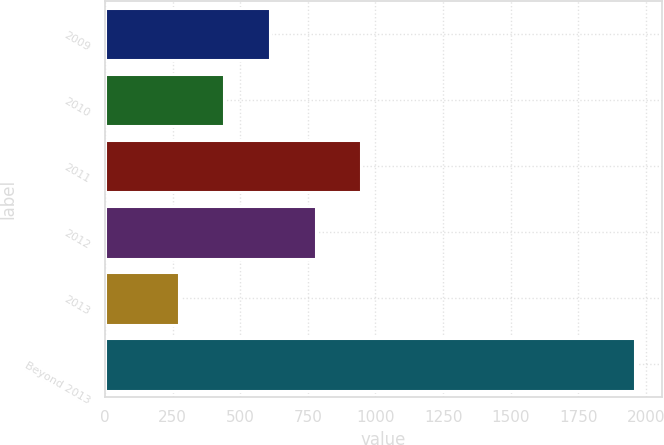Convert chart. <chart><loc_0><loc_0><loc_500><loc_500><bar_chart><fcel>2009<fcel>2010<fcel>2011<fcel>2012<fcel>2013<fcel>Beyond 2013<nl><fcel>610.4<fcel>441.7<fcel>947.8<fcel>779.1<fcel>273<fcel>1960<nl></chart> 